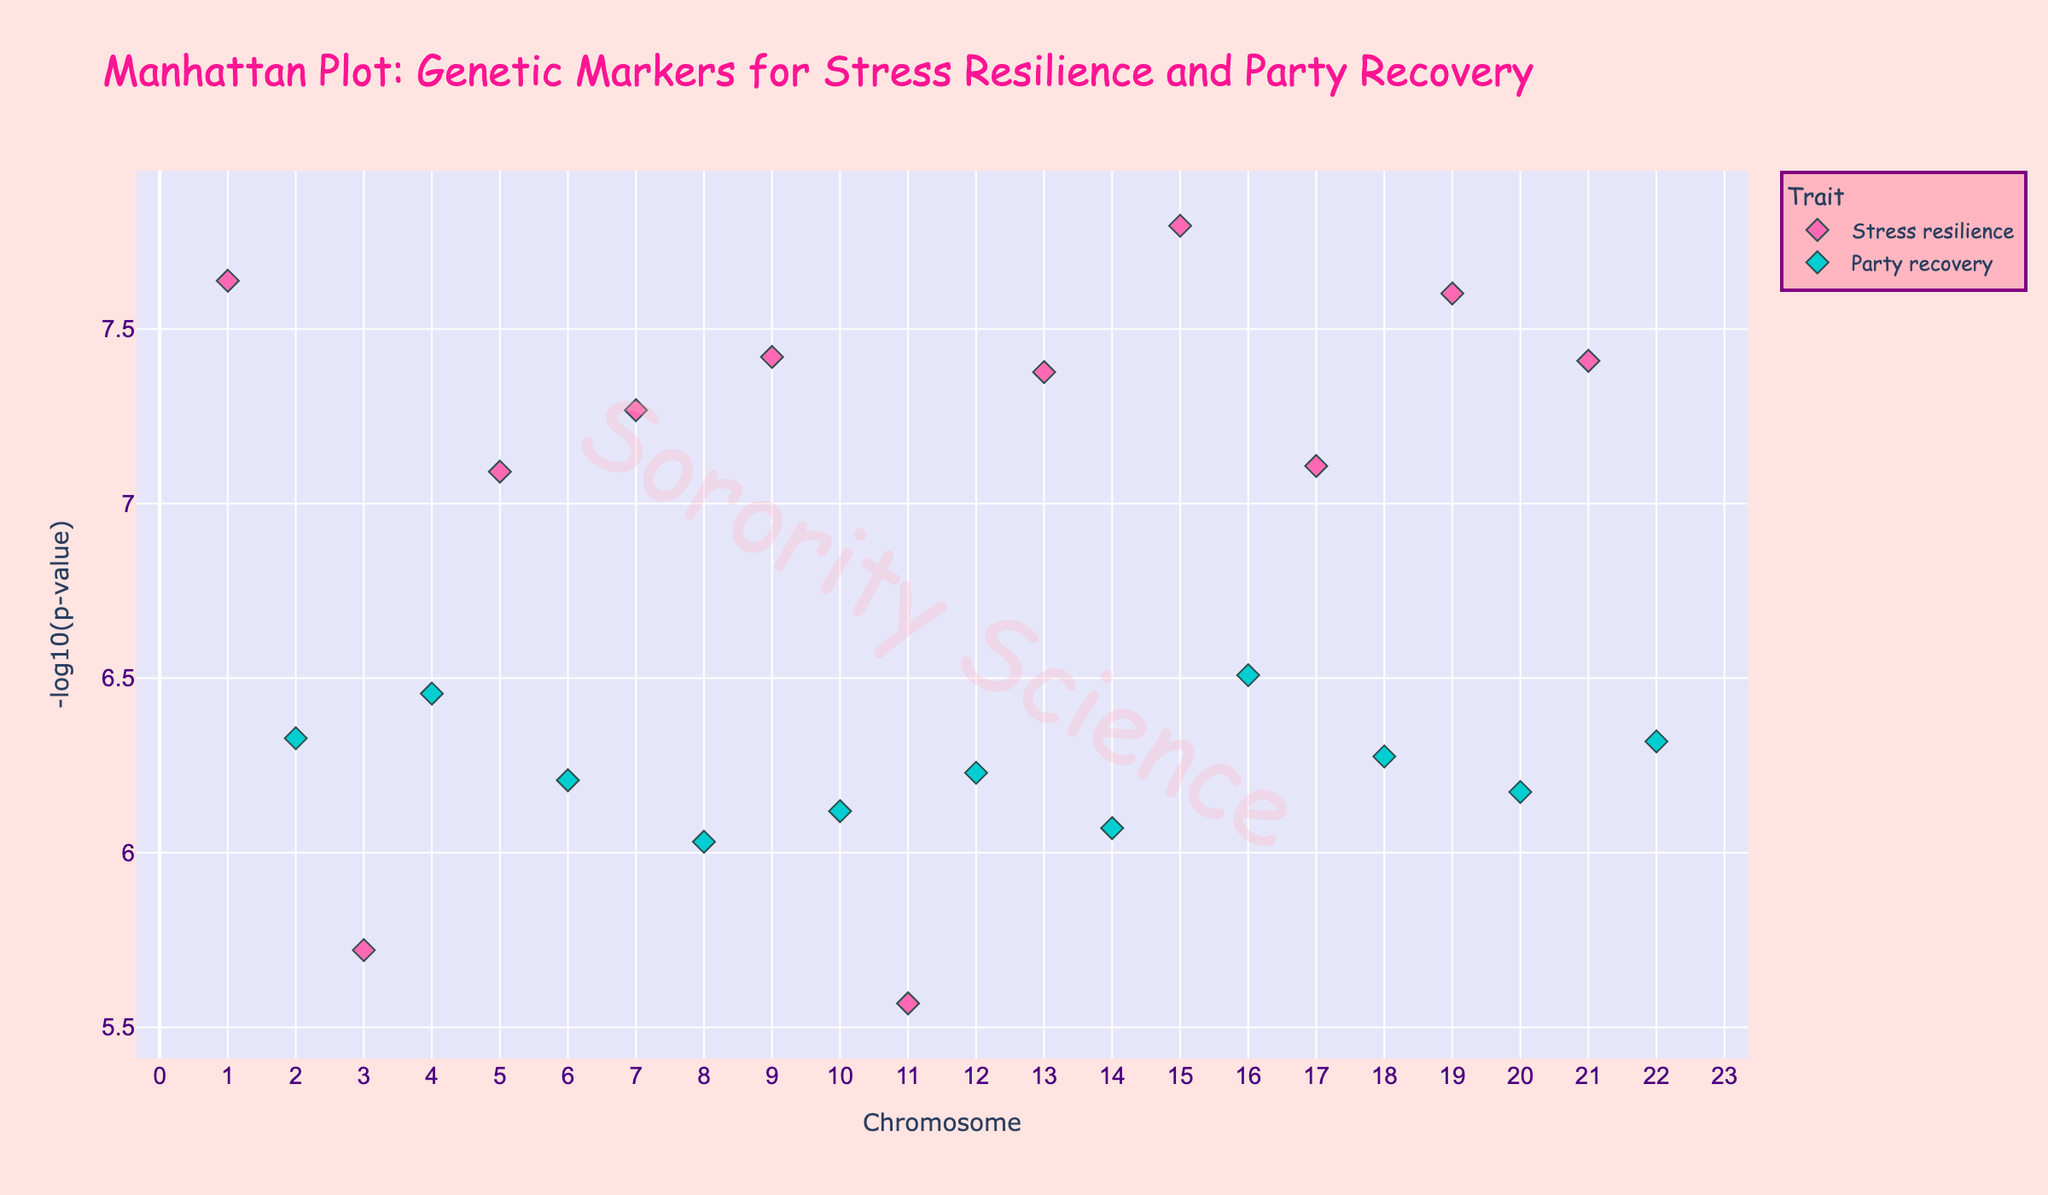What are the two chromosomes with the highest -log10(p-value) for Stress resilience? To find which chromosomes have the highest -log10(p-value) for Stress resilience, we look for the highest points marked in pink (the color consistent with Stress resilience) on the y-axis. By identifying these points, we can then check the x-axis for their corresponding chromosomes. The two highest points in pink are on Chromosomes 1 and 15.
Answer: Chromosomes 1 and 15 Which gene associated with Party recovery on Chromosome 8 has the lowest P-value? On Chromosome 8 marked by the x-axis, look for the point with light blue color representing Party recovery. From this point, check its position on the y-axis to find its -log10(p-value) and the given gene text. The gene associated with Party recovery on Chromosome 8 is GABRA2.
Answer: GABRA2 What is the approximate -log10(p-value) for gene NPY, associated with Stress resilience? Locate the gene NPY by searching for its corresponding trait, Stress resilience, marked in pink. Once you find the data point, determine its y-axis value. The -log10(p-value) for Stress resilience with gene NPY is approximately 7.07.
Answer: 7.07 Which trait has more genetic markers plotted on this Manhattan plot? Count the number of data points for each trait type. Since Stress resilience is indicated by pink and Party recovery by light blue, it’s clear that Stress resilience has more genetic markers plotted.
Answer: Stress resilience Between genes CRHR1 (Party recovery on Chromosome 4) and BDNF (Stress resilience on Chromosome 9), which has a more significant P-value? To compare P-values, we look at their -log10(p-value) values on the y-axis. A higher -log10(p-value) indicates a smaller P-value. CRHR1 has a y-value of about 6.15, and BDNF has a y-value of about 7.42. Therefore, BDNF (with a higher -log10(p-value)) is more significant.
Answer: BDNF Which chromosome houses the most significant genetic marker for Party recovery, and which gene is it? For the most significant genetic marker, determine which data point in light blue (indicating Party recovery) reaches the highest value on the y-axis. The highest light blue point appears on Chromosome 4, marking the gene CRHR1.
Answer: Chromosome 4, CRHR1 What is the total number of chromosomes represented in the Manhattan plot? Count the distinct chromosome numbers along the x-axis, which ranges from 1 to 22. Since each number appears, there are 22 chromosomes represented in the plot.
Answer: 22 How does the -log10(p-value) for TPH2 on Chromosome 19 compare to FAAH on Chromosome 21 for Stress resilience? Locate the points corresponding to TPH2 associated with Stress resilience on Chromosome 19 and FAAH on Chromosome 21. Check their vertical positions on the y-axis representing -log10(p-value). TPH2 has a y-value of approximately 7.60, while FAAH has approximately 7.41. TPH2 has a slightly higher -log10(p-value), indicating greater significance.
Answer: TPH2 has a higher -log10(p-value) What is the range of -log10(p-value) values shown on the y-axis? The y-axis ranges from 0 to 10 in the plot, indicating the lower and upper bounds of the -log10(p-value) values represented.
Answer: 0 to 10 